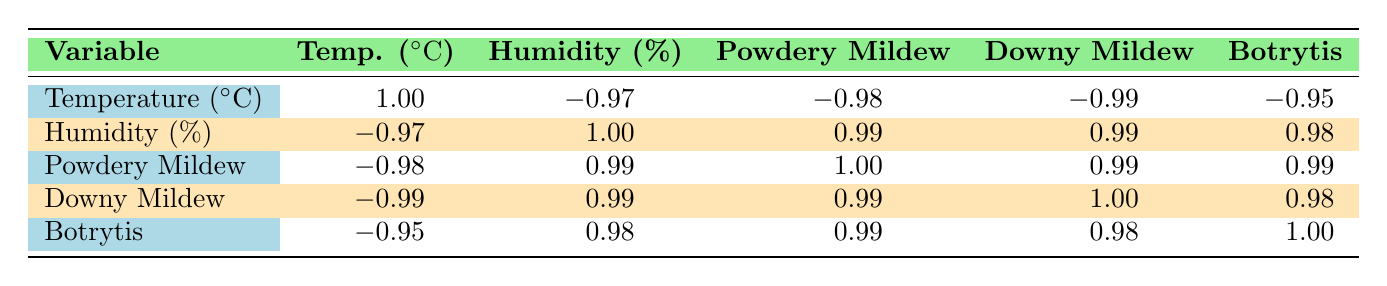What is the correlation between temperature and powdery mildew prevalence? The table shows that the correlation between temperature and powdery mildew prevalence is -0.98. This indicates a strong negative correlation, meaning as temperature increases, powdery mildew prevalence tends to decrease.
Answer: -0.98 What is the highest prevalence of downy mildew recorded in the table? By reviewing the downy mildew prevalence values from the table, the highest prevalence is 45, which occurs at 18 degrees Celsius and 85% humidity.
Answer: 45 Is there a positive correlation between humidity and botrytis bunch rot prevalence? Yes, the correlation between humidity and botrytis bunch rot prevalence is 0.98, indicating a strong positive relationship where increased humidity results in higher botrytis prevalence.
Answer: Yes What is the difference in powdery mildew prevalence between the highest and lowest recorded values? The highest powdery mildew prevalence is 30 (at 18 degrees Celsius and 85% humidity) and the lowest is 5 (at 35 degrees Celsius and 40% humidity). The difference is 30 - 5 = 25.
Answer: 25 What is the average humidity for the data points provided? To find the average humidity, sum the humidity values (80 + 70 + 60 + 50 + 40 + 85 = 385) and divide by the number of data points (6). Hence, the average humidity is 385/6 = 64.17.
Answer: 64.17 Is the correlation of downy mildew with powdery mildew greater than with humidity? The correlation of downy mildew with powdery mildew is 0.99, while with humidity it is also 0.99. Since both correlations are equal, we state that downy mildew's correlation with powdery mildew is not greater than with humidity; they are the same.
Answer: No 